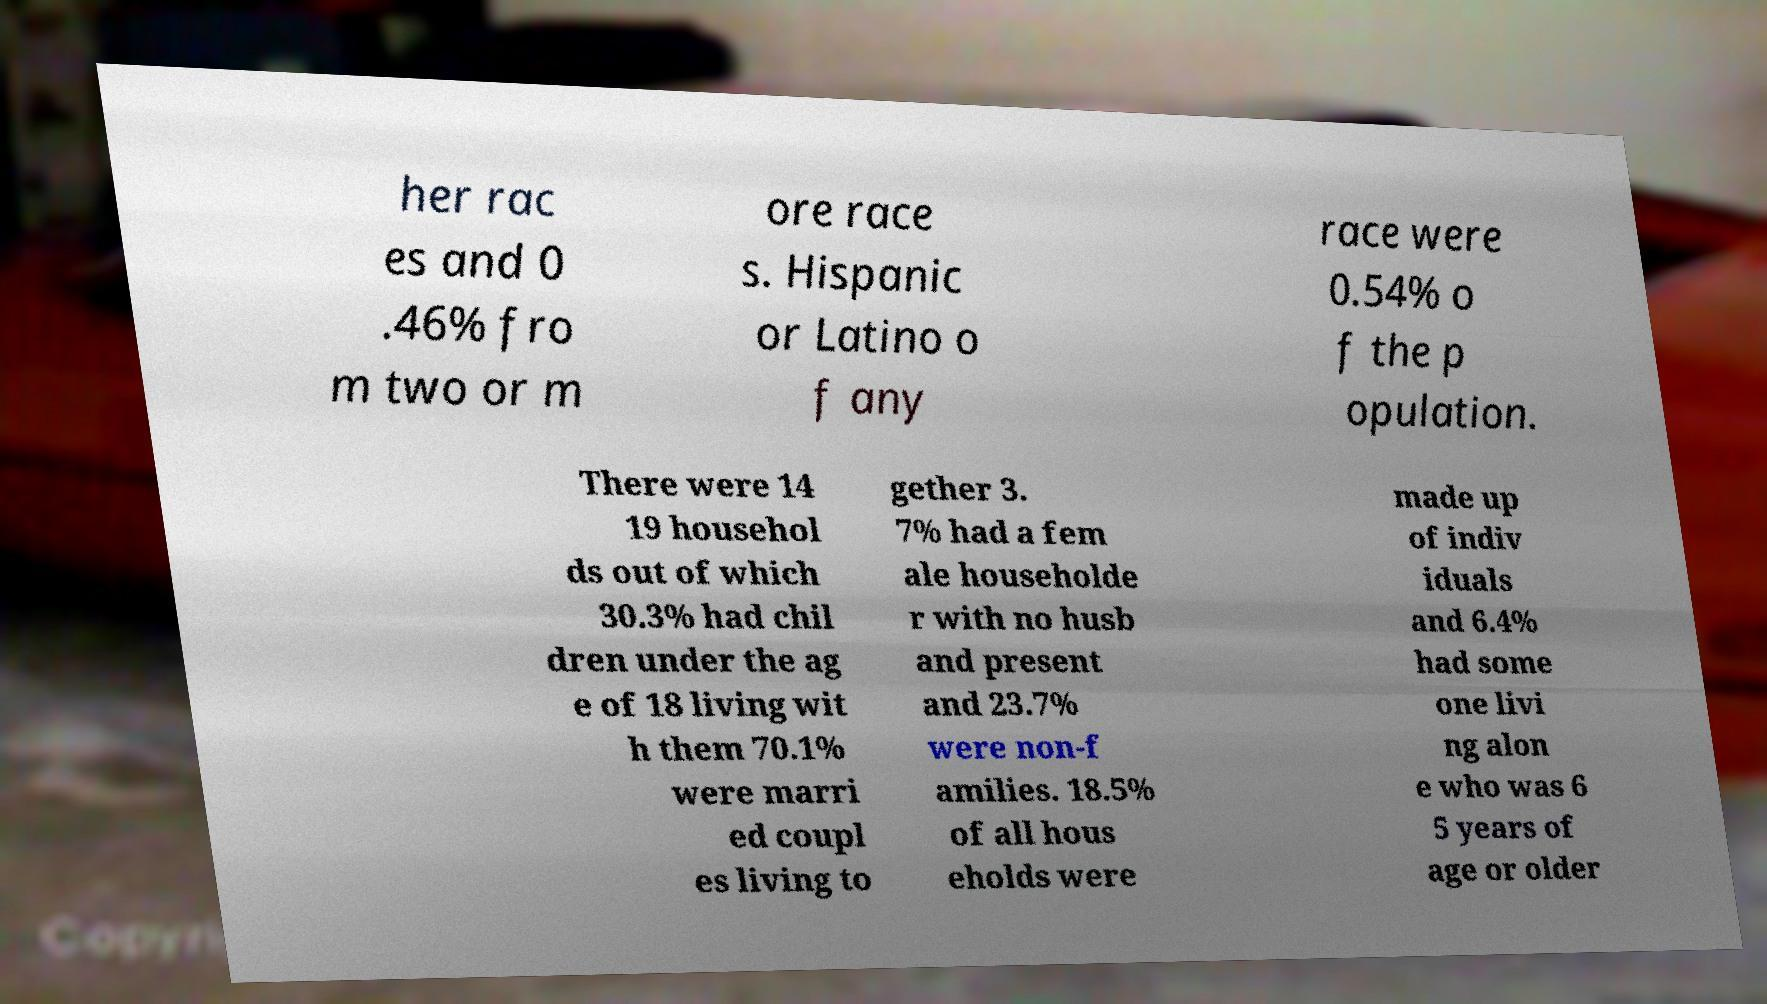I need the written content from this picture converted into text. Can you do that? her rac es and 0 .46% fro m two or m ore race s. Hispanic or Latino o f any race were 0.54% o f the p opulation. There were 14 19 househol ds out of which 30.3% had chil dren under the ag e of 18 living wit h them 70.1% were marri ed coupl es living to gether 3. 7% had a fem ale householde r with no husb and present and 23.7% were non-f amilies. 18.5% of all hous eholds were made up of indiv iduals and 6.4% had some one livi ng alon e who was 6 5 years of age or older 